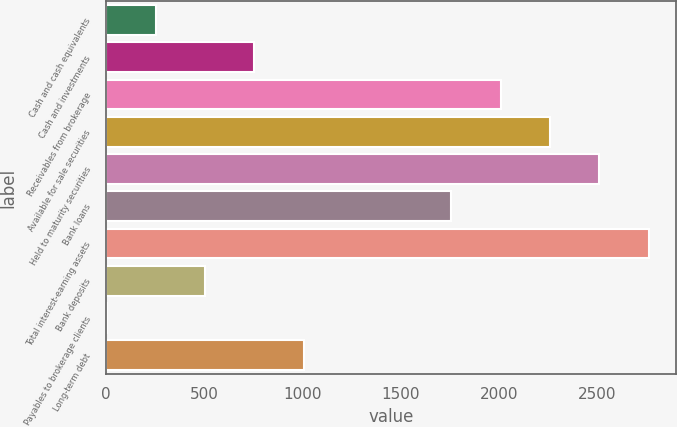Convert chart to OTSL. <chart><loc_0><loc_0><loc_500><loc_500><bar_chart><fcel>Cash and cash equivalents<fcel>Cash and investments<fcel>Receivables from brokerage<fcel>Available for sale securities<fcel>Held to maturity securities<fcel>Bank loans<fcel>Total interest-earning assets<fcel>Bank deposits<fcel>Payables to brokerage clients<fcel>Long-term debt<nl><fcel>253<fcel>755<fcel>2010<fcel>2261<fcel>2512<fcel>1759<fcel>2763<fcel>504<fcel>2<fcel>1006<nl></chart> 